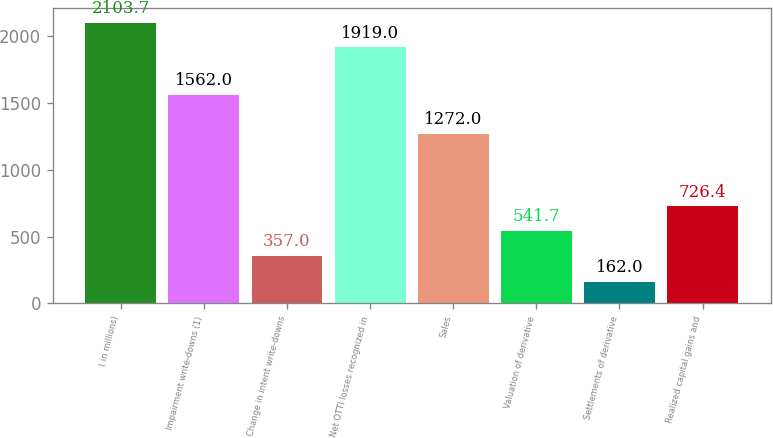Convert chart to OTSL. <chart><loc_0><loc_0><loc_500><loc_500><bar_chart><fcel>( in millions)<fcel>Impairment write-downs (1)<fcel>Change in intent write-downs<fcel>Net OTTI losses recognized in<fcel>Sales<fcel>Valuation of derivative<fcel>Settlements of derivative<fcel>Realized capital gains and<nl><fcel>2103.7<fcel>1562<fcel>357<fcel>1919<fcel>1272<fcel>541.7<fcel>162<fcel>726.4<nl></chart> 